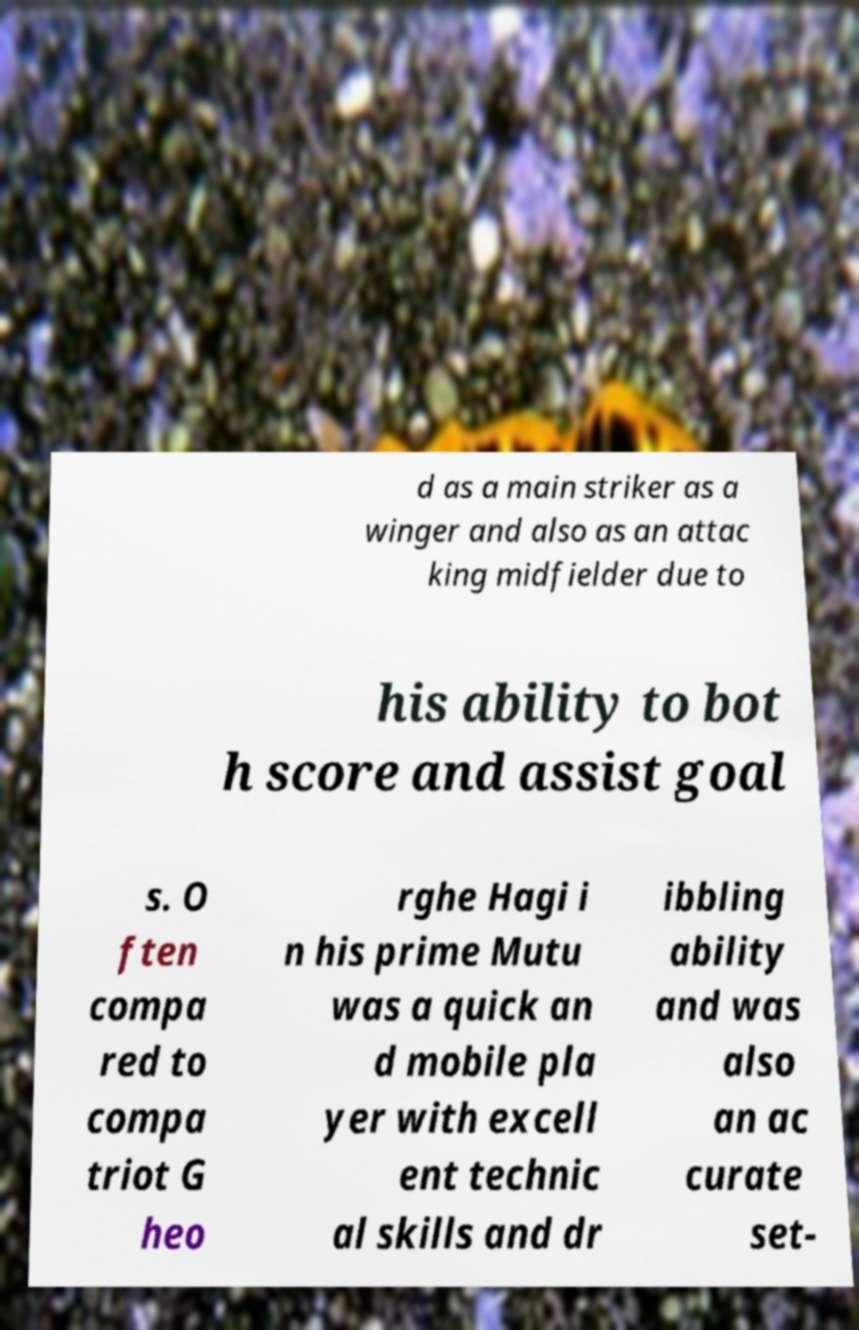There's text embedded in this image that I need extracted. Can you transcribe it verbatim? d as a main striker as a winger and also as an attac king midfielder due to his ability to bot h score and assist goal s. O ften compa red to compa triot G heo rghe Hagi i n his prime Mutu was a quick an d mobile pla yer with excell ent technic al skills and dr ibbling ability and was also an ac curate set- 